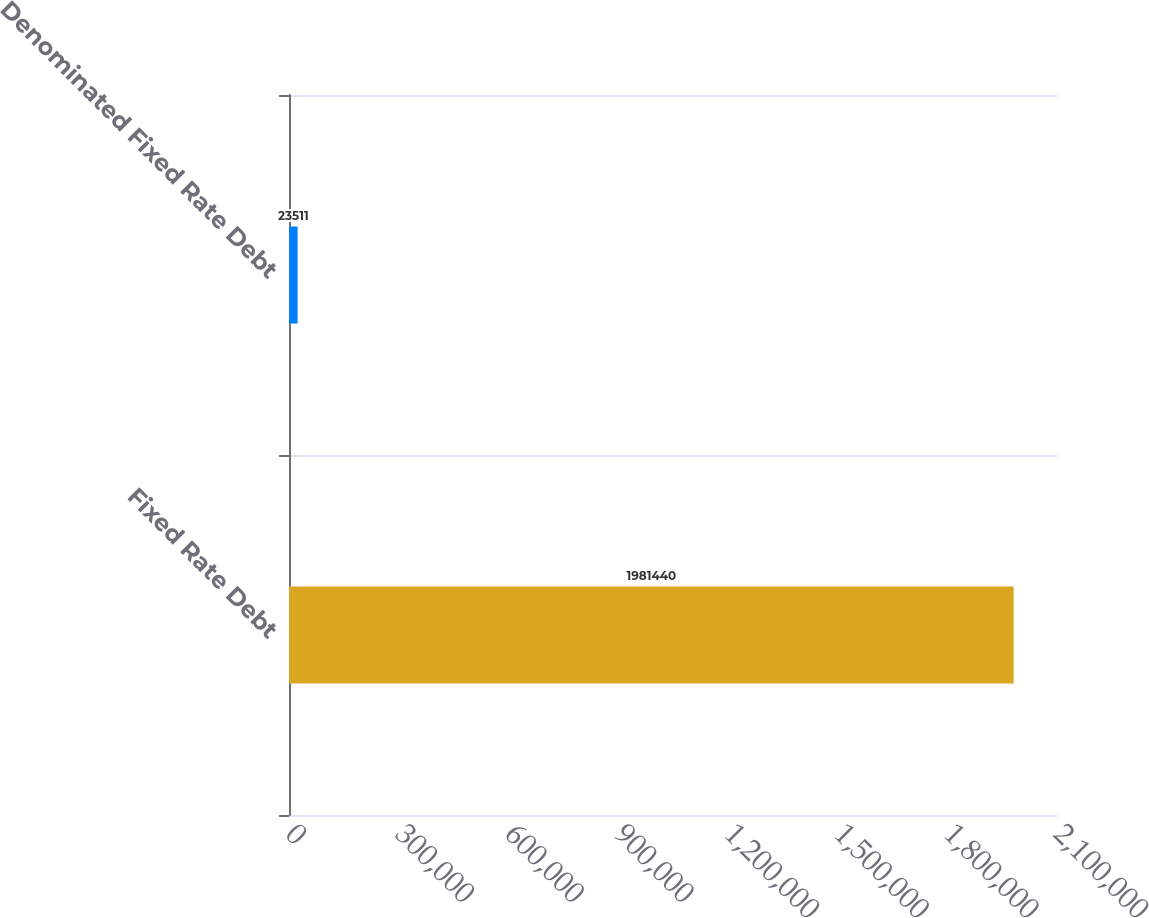Convert chart to OTSL. <chart><loc_0><loc_0><loc_500><loc_500><bar_chart><fcel>Fixed Rate Debt<fcel>Denominated Fixed Rate Debt<nl><fcel>1.98144e+06<fcel>23511<nl></chart> 